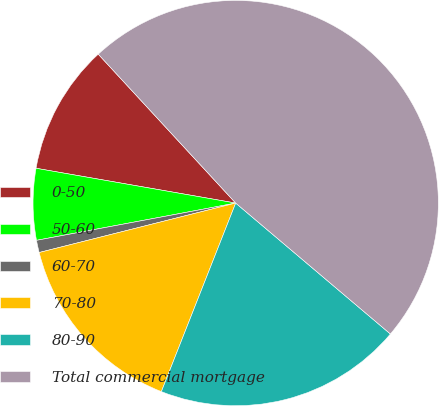Convert chart. <chart><loc_0><loc_0><loc_500><loc_500><pie_chart><fcel>0-50<fcel>50-60<fcel>60-70<fcel>70-80<fcel>80-90<fcel>Total commercial mortgage<nl><fcel>10.39%<fcel>5.69%<fcel>0.98%<fcel>15.1%<fcel>19.8%<fcel>48.04%<nl></chart> 